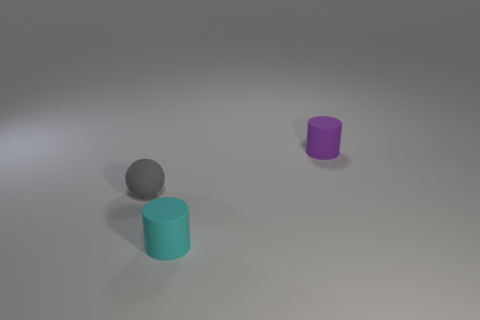Add 1 gray things. How many objects exist? 4 Subtract all cylinders. How many objects are left? 1 Subtract all small brown cylinders. Subtract all tiny cyan rubber cylinders. How many objects are left? 2 Add 1 small spheres. How many small spheres are left? 2 Add 3 tiny purple matte things. How many tiny purple matte things exist? 4 Subtract 0 yellow spheres. How many objects are left? 3 